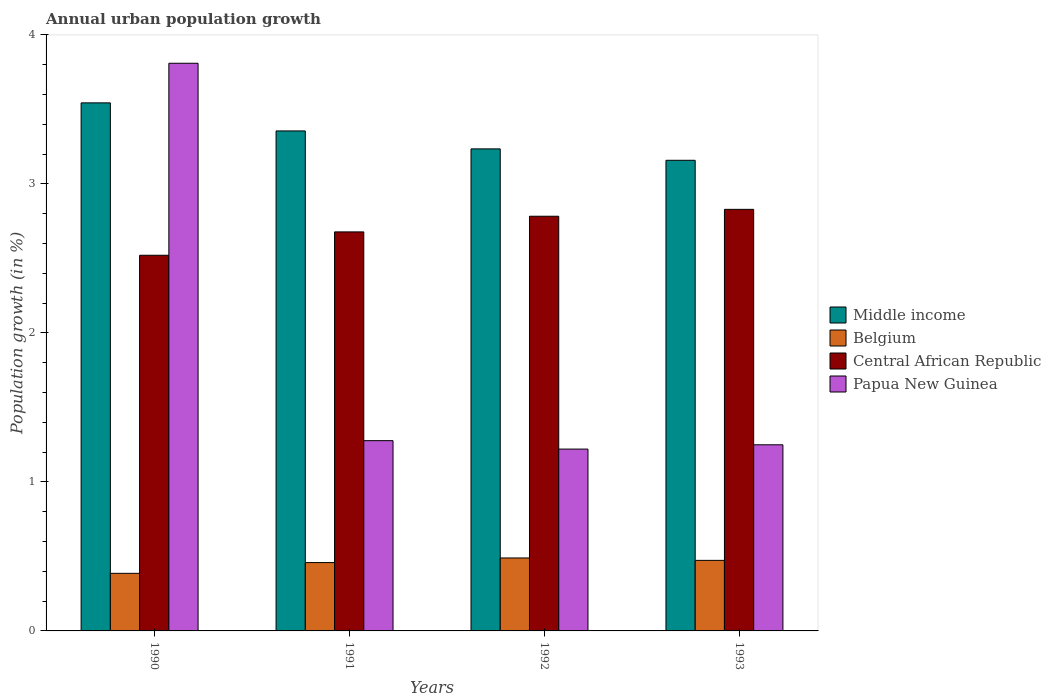Are the number of bars per tick equal to the number of legend labels?
Keep it short and to the point. Yes. Are the number of bars on each tick of the X-axis equal?
Offer a very short reply. Yes. How many bars are there on the 2nd tick from the right?
Your response must be concise. 4. What is the label of the 4th group of bars from the left?
Provide a succinct answer. 1993. What is the percentage of urban population growth in Middle income in 1990?
Offer a terse response. 3.54. Across all years, what is the maximum percentage of urban population growth in Middle income?
Offer a very short reply. 3.54. Across all years, what is the minimum percentage of urban population growth in Central African Republic?
Offer a terse response. 2.52. In which year was the percentage of urban population growth in Belgium minimum?
Your response must be concise. 1990. What is the total percentage of urban population growth in Papua New Guinea in the graph?
Your answer should be very brief. 7.56. What is the difference between the percentage of urban population growth in Belgium in 1990 and that in 1992?
Your answer should be very brief. -0.1. What is the difference between the percentage of urban population growth in Middle income in 1993 and the percentage of urban population growth in Papua New Guinea in 1990?
Ensure brevity in your answer.  -0.65. What is the average percentage of urban population growth in Central African Republic per year?
Ensure brevity in your answer.  2.7. In the year 1991, what is the difference between the percentage of urban population growth in Belgium and percentage of urban population growth in Papua New Guinea?
Make the answer very short. -0.82. What is the ratio of the percentage of urban population growth in Papua New Guinea in 1991 to that in 1992?
Keep it short and to the point. 1.05. What is the difference between the highest and the second highest percentage of urban population growth in Central African Republic?
Keep it short and to the point. 0.05. What is the difference between the highest and the lowest percentage of urban population growth in Middle income?
Make the answer very short. 0.39. Is it the case that in every year, the sum of the percentage of urban population growth in Papua New Guinea and percentage of urban population growth in Belgium is greater than the sum of percentage of urban population growth in Middle income and percentage of urban population growth in Central African Republic?
Offer a very short reply. No. What does the 1st bar from the left in 1991 represents?
Give a very brief answer. Middle income. What does the 2nd bar from the right in 1991 represents?
Your answer should be very brief. Central African Republic. How many years are there in the graph?
Provide a short and direct response. 4. What is the difference between two consecutive major ticks on the Y-axis?
Offer a terse response. 1. Where does the legend appear in the graph?
Your answer should be compact. Center right. How many legend labels are there?
Provide a short and direct response. 4. What is the title of the graph?
Keep it short and to the point. Annual urban population growth. What is the label or title of the Y-axis?
Your response must be concise. Population growth (in %). What is the Population growth (in %) of Middle income in 1990?
Your answer should be very brief. 3.54. What is the Population growth (in %) in Belgium in 1990?
Offer a very short reply. 0.39. What is the Population growth (in %) of Central African Republic in 1990?
Offer a terse response. 2.52. What is the Population growth (in %) in Papua New Guinea in 1990?
Keep it short and to the point. 3.81. What is the Population growth (in %) in Middle income in 1991?
Offer a very short reply. 3.36. What is the Population growth (in %) in Belgium in 1991?
Offer a very short reply. 0.46. What is the Population growth (in %) of Central African Republic in 1991?
Keep it short and to the point. 2.68. What is the Population growth (in %) of Papua New Guinea in 1991?
Your answer should be very brief. 1.28. What is the Population growth (in %) of Middle income in 1992?
Make the answer very short. 3.24. What is the Population growth (in %) of Belgium in 1992?
Give a very brief answer. 0.49. What is the Population growth (in %) of Central African Republic in 1992?
Offer a terse response. 2.78. What is the Population growth (in %) in Papua New Guinea in 1992?
Your answer should be very brief. 1.22. What is the Population growth (in %) of Middle income in 1993?
Ensure brevity in your answer.  3.16. What is the Population growth (in %) of Belgium in 1993?
Ensure brevity in your answer.  0.47. What is the Population growth (in %) of Central African Republic in 1993?
Keep it short and to the point. 2.83. What is the Population growth (in %) in Papua New Guinea in 1993?
Ensure brevity in your answer.  1.25. Across all years, what is the maximum Population growth (in %) in Middle income?
Your answer should be very brief. 3.54. Across all years, what is the maximum Population growth (in %) in Belgium?
Make the answer very short. 0.49. Across all years, what is the maximum Population growth (in %) in Central African Republic?
Your answer should be compact. 2.83. Across all years, what is the maximum Population growth (in %) in Papua New Guinea?
Provide a short and direct response. 3.81. Across all years, what is the minimum Population growth (in %) in Middle income?
Your answer should be very brief. 3.16. Across all years, what is the minimum Population growth (in %) of Belgium?
Give a very brief answer. 0.39. Across all years, what is the minimum Population growth (in %) in Central African Republic?
Ensure brevity in your answer.  2.52. Across all years, what is the minimum Population growth (in %) in Papua New Guinea?
Make the answer very short. 1.22. What is the total Population growth (in %) of Middle income in the graph?
Offer a terse response. 13.29. What is the total Population growth (in %) of Belgium in the graph?
Offer a very short reply. 1.81. What is the total Population growth (in %) of Central African Republic in the graph?
Your answer should be compact. 10.81. What is the total Population growth (in %) of Papua New Guinea in the graph?
Keep it short and to the point. 7.56. What is the difference between the Population growth (in %) in Middle income in 1990 and that in 1991?
Offer a terse response. 0.19. What is the difference between the Population growth (in %) of Belgium in 1990 and that in 1991?
Your answer should be very brief. -0.07. What is the difference between the Population growth (in %) of Central African Republic in 1990 and that in 1991?
Your response must be concise. -0.16. What is the difference between the Population growth (in %) of Papua New Guinea in 1990 and that in 1991?
Offer a terse response. 2.53. What is the difference between the Population growth (in %) of Middle income in 1990 and that in 1992?
Provide a succinct answer. 0.31. What is the difference between the Population growth (in %) of Belgium in 1990 and that in 1992?
Give a very brief answer. -0.1. What is the difference between the Population growth (in %) of Central African Republic in 1990 and that in 1992?
Provide a short and direct response. -0.26. What is the difference between the Population growth (in %) in Papua New Guinea in 1990 and that in 1992?
Make the answer very short. 2.59. What is the difference between the Population growth (in %) of Middle income in 1990 and that in 1993?
Keep it short and to the point. 0.39. What is the difference between the Population growth (in %) of Belgium in 1990 and that in 1993?
Your response must be concise. -0.09. What is the difference between the Population growth (in %) of Central African Republic in 1990 and that in 1993?
Your answer should be compact. -0.31. What is the difference between the Population growth (in %) of Papua New Guinea in 1990 and that in 1993?
Make the answer very short. 2.56. What is the difference between the Population growth (in %) of Middle income in 1991 and that in 1992?
Give a very brief answer. 0.12. What is the difference between the Population growth (in %) of Belgium in 1991 and that in 1992?
Make the answer very short. -0.03. What is the difference between the Population growth (in %) in Central African Republic in 1991 and that in 1992?
Your response must be concise. -0.1. What is the difference between the Population growth (in %) of Papua New Guinea in 1991 and that in 1992?
Keep it short and to the point. 0.06. What is the difference between the Population growth (in %) in Middle income in 1991 and that in 1993?
Provide a short and direct response. 0.2. What is the difference between the Population growth (in %) of Belgium in 1991 and that in 1993?
Offer a very short reply. -0.01. What is the difference between the Population growth (in %) of Central African Republic in 1991 and that in 1993?
Provide a short and direct response. -0.15. What is the difference between the Population growth (in %) in Papua New Guinea in 1991 and that in 1993?
Make the answer very short. 0.03. What is the difference between the Population growth (in %) in Middle income in 1992 and that in 1993?
Offer a terse response. 0.08. What is the difference between the Population growth (in %) in Belgium in 1992 and that in 1993?
Offer a very short reply. 0.02. What is the difference between the Population growth (in %) in Central African Republic in 1992 and that in 1993?
Offer a terse response. -0.05. What is the difference between the Population growth (in %) of Papua New Guinea in 1992 and that in 1993?
Keep it short and to the point. -0.03. What is the difference between the Population growth (in %) of Middle income in 1990 and the Population growth (in %) of Belgium in 1991?
Your response must be concise. 3.09. What is the difference between the Population growth (in %) of Middle income in 1990 and the Population growth (in %) of Central African Republic in 1991?
Provide a short and direct response. 0.87. What is the difference between the Population growth (in %) of Middle income in 1990 and the Population growth (in %) of Papua New Guinea in 1991?
Provide a short and direct response. 2.27. What is the difference between the Population growth (in %) in Belgium in 1990 and the Population growth (in %) in Central African Republic in 1991?
Provide a succinct answer. -2.29. What is the difference between the Population growth (in %) of Belgium in 1990 and the Population growth (in %) of Papua New Guinea in 1991?
Your answer should be compact. -0.89. What is the difference between the Population growth (in %) in Central African Republic in 1990 and the Population growth (in %) in Papua New Guinea in 1991?
Make the answer very short. 1.24. What is the difference between the Population growth (in %) of Middle income in 1990 and the Population growth (in %) of Belgium in 1992?
Make the answer very short. 3.05. What is the difference between the Population growth (in %) of Middle income in 1990 and the Population growth (in %) of Central African Republic in 1992?
Give a very brief answer. 0.76. What is the difference between the Population growth (in %) in Middle income in 1990 and the Population growth (in %) in Papua New Guinea in 1992?
Ensure brevity in your answer.  2.32. What is the difference between the Population growth (in %) of Belgium in 1990 and the Population growth (in %) of Central African Republic in 1992?
Make the answer very short. -2.4. What is the difference between the Population growth (in %) of Belgium in 1990 and the Population growth (in %) of Papua New Guinea in 1992?
Your answer should be very brief. -0.83. What is the difference between the Population growth (in %) of Central African Republic in 1990 and the Population growth (in %) of Papua New Guinea in 1992?
Offer a very short reply. 1.3. What is the difference between the Population growth (in %) in Middle income in 1990 and the Population growth (in %) in Belgium in 1993?
Your answer should be compact. 3.07. What is the difference between the Population growth (in %) in Middle income in 1990 and the Population growth (in %) in Central African Republic in 1993?
Offer a very short reply. 0.71. What is the difference between the Population growth (in %) in Middle income in 1990 and the Population growth (in %) in Papua New Guinea in 1993?
Provide a succinct answer. 2.29. What is the difference between the Population growth (in %) in Belgium in 1990 and the Population growth (in %) in Central African Republic in 1993?
Keep it short and to the point. -2.44. What is the difference between the Population growth (in %) in Belgium in 1990 and the Population growth (in %) in Papua New Guinea in 1993?
Your answer should be very brief. -0.86. What is the difference between the Population growth (in %) in Central African Republic in 1990 and the Population growth (in %) in Papua New Guinea in 1993?
Ensure brevity in your answer.  1.27. What is the difference between the Population growth (in %) in Middle income in 1991 and the Population growth (in %) in Belgium in 1992?
Keep it short and to the point. 2.87. What is the difference between the Population growth (in %) of Middle income in 1991 and the Population growth (in %) of Central African Republic in 1992?
Keep it short and to the point. 0.57. What is the difference between the Population growth (in %) in Middle income in 1991 and the Population growth (in %) in Papua New Guinea in 1992?
Ensure brevity in your answer.  2.14. What is the difference between the Population growth (in %) in Belgium in 1991 and the Population growth (in %) in Central African Republic in 1992?
Provide a succinct answer. -2.32. What is the difference between the Population growth (in %) of Belgium in 1991 and the Population growth (in %) of Papua New Guinea in 1992?
Make the answer very short. -0.76. What is the difference between the Population growth (in %) in Central African Republic in 1991 and the Population growth (in %) in Papua New Guinea in 1992?
Your answer should be very brief. 1.46. What is the difference between the Population growth (in %) of Middle income in 1991 and the Population growth (in %) of Belgium in 1993?
Your answer should be compact. 2.88. What is the difference between the Population growth (in %) in Middle income in 1991 and the Population growth (in %) in Central African Republic in 1993?
Your answer should be very brief. 0.53. What is the difference between the Population growth (in %) of Middle income in 1991 and the Population growth (in %) of Papua New Guinea in 1993?
Ensure brevity in your answer.  2.11. What is the difference between the Population growth (in %) in Belgium in 1991 and the Population growth (in %) in Central African Republic in 1993?
Give a very brief answer. -2.37. What is the difference between the Population growth (in %) of Belgium in 1991 and the Population growth (in %) of Papua New Guinea in 1993?
Offer a very short reply. -0.79. What is the difference between the Population growth (in %) in Central African Republic in 1991 and the Population growth (in %) in Papua New Guinea in 1993?
Your answer should be very brief. 1.43. What is the difference between the Population growth (in %) of Middle income in 1992 and the Population growth (in %) of Belgium in 1993?
Provide a succinct answer. 2.76. What is the difference between the Population growth (in %) in Middle income in 1992 and the Population growth (in %) in Central African Republic in 1993?
Keep it short and to the point. 0.41. What is the difference between the Population growth (in %) in Middle income in 1992 and the Population growth (in %) in Papua New Guinea in 1993?
Provide a short and direct response. 1.99. What is the difference between the Population growth (in %) of Belgium in 1992 and the Population growth (in %) of Central African Republic in 1993?
Keep it short and to the point. -2.34. What is the difference between the Population growth (in %) in Belgium in 1992 and the Population growth (in %) in Papua New Guinea in 1993?
Make the answer very short. -0.76. What is the difference between the Population growth (in %) of Central African Republic in 1992 and the Population growth (in %) of Papua New Guinea in 1993?
Your answer should be compact. 1.53. What is the average Population growth (in %) in Middle income per year?
Provide a short and direct response. 3.32. What is the average Population growth (in %) in Belgium per year?
Provide a succinct answer. 0.45. What is the average Population growth (in %) of Central African Republic per year?
Provide a short and direct response. 2.7. What is the average Population growth (in %) of Papua New Guinea per year?
Make the answer very short. 1.89. In the year 1990, what is the difference between the Population growth (in %) of Middle income and Population growth (in %) of Belgium?
Offer a very short reply. 3.16. In the year 1990, what is the difference between the Population growth (in %) in Middle income and Population growth (in %) in Central African Republic?
Your response must be concise. 1.02. In the year 1990, what is the difference between the Population growth (in %) of Middle income and Population growth (in %) of Papua New Guinea?
Make the answer very short. -0.27. In the year 1990, what is the difference between the Population growth (in %) in Belgium and Population growth (in %) in Central African Republic?
Offer a terse response. -2.13. In the year 1990, what is the difference between the Population growth (in %) in Belgium and Population growth (in %) in Papua New Guinea?
Give a very brief answer. -3.42. In the year 1990, what is the difference between the Population growth (in %) in Central African Republic and Population growth (in %) in Papua New Guinea?
Provide a short and direct response. -1.29. In the year 1991, what is the difference between the Population growth (in %) in Middle income and Population growth (in %) in Belgium?
Your response must be concise. 2.9. In the year 1991, what is the difference between the Population growth (in %) of Middle income and Population growth (in %) of Central African Republic?
Your answer should be very brief. 0.68. In the year 1991, what is the difference between the Population growth (in %) in Middle income and Population growth (in %) in Papua New Guinea?
Provide a short and direct response. 2.08. In the year 1991, what is the difference between the Population growth (in %) in Belgium and Population growth (in %) in Central African Republic?
Provide a succinct answer. -2.22. In the year 1991, what is the difference between the Population growth (in %) of Belgium and Population growth (in %) of Papua New Guinea?
Offer a terse response. -0.82. In the year 1991, what is the difference between the Population growth (in %) of Central African Republic and Population growth (in %) of Papua New Guinea?
Offer a terse response. 1.4. In the year 1992, what is the difference between the Population growth (in %) in Middle income and Population growth (in %) in Belgium?
Offer a very short reply. 2.75. In the year 1992, what is the difference between the Population growth (in %) of Middle income and Population growth (in %) of Central African Republic?
Your answer should be compact. 0.45. In the year 1992, what is the difference between the Population growth (in %) in Middle income and Population growth (in %) in Papua New Guinea?
Ensure brevity in your answer.  2.01. In the year 1992, what is the difference between the Population growth (in %) in Belgium and Population growth (in %) in Central African Republic?
Make the answer very short. -2.29. In the year 1992, what is the difference between the Population growth (in %) of Belgium and Population growth (in %) of Papua New Guinea?
Your answer should be very brief. -0.73. In the year 1992, what is the difference between the Population growth (in %) of Central African Republic and Population growth (in %) of Papua New Guinea?
Make the answer very short. 1.56. In the year 1993, what is the difference between the Population growth (in %) of Middle income and Population growth (in %) of Belgium?
Offer a terse response. 2.69. In the year 1993, what is the difference between the Population growth (in %) in Middle income and Population growth (in %) in Central African Republic?
Keep it short and to the point. 0.33. In the year 1993, what is the difference between the Population growth (in %) of Middle income and Population growth (in %) of Papua New Guinea?
Offer a very short reply. 1.91. In the year 1993, what is the difference between the Population growth (in %) in Belgium and Population growth (in %) in Central African Republic?
Keep it short and to the point. -2.36. In the year 1993, what is the difference between the Population growth (in %) in Belgium and Population growth (in %) in Papua New Guinea?
Keep it short and to the point. -0.78. In the year 1993, what is the difference between the Population growth (in %) in Central African Republic and Population growth (in %) in Papua New Guinea?
Ensure brevity in your answer.  1.58. What is the ratio of the Population growth (in %) in Middle income in 1990 to that in 1991?
Ensure brevity in your answer.  1.06. What is the ratio of the Population growth (in %) in Belgium in 1990 to that in 1991?
Offer a terse response. 0.84. What is the ratio of the Population growth (in %) of Central African Republic in 1990 to that in 1991?
Offer a very short reply. 0.94. What is the ratio of the Population growth (in %) in Papua New Guinea in 1990 to that in 1991?
Keep it short and to the point. 2.98. What is the ratio of the Population growth (in %) in Middle income in 1990 to that in 1992?
Your response must be concise. 1.1. What is the ratio of the Population growth (in %) in Belgium in 1990 to that in 1992?
Offer a very short reply. 0.79. What is the ratio of the Population growth (in %) in Central African Republic in 1990 to that in 1992?
Your response must be concise. 0.91. What is the ratio of the Population growth (in %) in Papua New Guinea in 1990 to that in 1992?
Give a very brief answer. 3.12. What is the ratio of the Population growth (in %) in Middle income in 1990 to that in 1993?
Offer a terse response. 1.12. What is the ratio of the Population growth (in %) in Belgium in 1990 to that in 1993?
Provide a short and direct response. 0.82. What is the ratio of the Population growth (in %) in Central African Republic in 1990 to that in 1993?
Offer a terse response. 0.89. What is the ratio of the Population growth (in %) of Papua New Guinea in 1990 to that in 1993?
Make the answer very short. 3.05. What is the ratio of the Population growth (in %) in Middle income in 1991 to that in 1992?
Provide a succinct answer. 1.04. What is the ratio of the Population growth (in %) of Belgium in 1991 to that in 1992?
Make the answer very short. 0.94. What is the ratio of the Population growth (in %) of Central African Republic in 1991 to that in 1992?
Provide a succinct answer. 0.96. What is the ratio of the Population growth (in %) of Papua New Guinea in 1991 to that in 1992?
Your answer should be compact. 1.05. What is the ratio of the Population growth (in %) of Middle income in 1991 to that in 1993?
Keep it short and to the point. 1.06. What is the ratio of the Population growth (in %) in Belgium in 1991 to that in 1993?
Keep it short and to the point. 0.97. What is the ratio of the Population growth (in %) in Central African Republic in 1991 to that in 1993?
Offer a terse response. 0.95. What is the ratio of the Population growth (in %) in Papua New Guinea in 1991 to that in 1993?
Your response must be concise. 1.02. What is the ratio of the Population growth (in %) in Middle income in 1992 to that in 1993?
Offer a terse response. 1.02. What is the ratio of the Population growth (in %) in Belgium in 1992 to that in 1993?
Make the answer very short. 1.03. What is the ratio of the Population growth (in %) of Central African Republic in 1992 to that in 1993?
Your answer should be compact. 0.98. What is the ratio of the Population growth (in %) of Papua New Guinea in 1992 to that in 1993?
Give a very brief answer. 0.98. What is the difference between the highest and the second highest Population growth (in %) of Middle income?
Give a very brief answer. 0.19. What is the difference between the highest and the second highest Population growth (in %) of Belgium?
Ensure brevity in your answer.  0.02. What is the difference between the highest and the second highest Population growth (in %) of Central African Republic?
Offer a terse response. 0.05. What is the difference between the highest and the second highest Population growth (in %) in Papua New Guinea?
Offer a terse response. 2.53. What is the difference between the highest and the lowest Population growth (in %) in Middle income?
Offer a terse response. 0.39. What is the difference between the highest and the lowest Population growth (in %) in Belgium?
Make the answer very short. 0.1. What is the difference between the highest and the lowest Population growth (in %) of Central African Republic?
Your answer should be very brief. 0.31. What is the difference between the highest and the lowest Population growth (in %) of Papua New Guinea?
Provide a succinct answer. 2.59. 